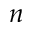Convert formula to latex. <formula><loc_0><loc_0><loc_500><loc_500>n</formula> 